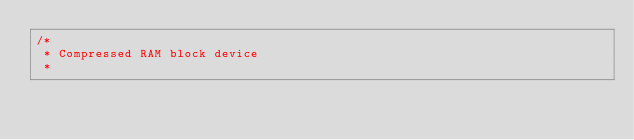<code> <loc_0><loc_0><loc_500><loc_500><_C_>/*
 * Compressed RAM block device
 *</code> 